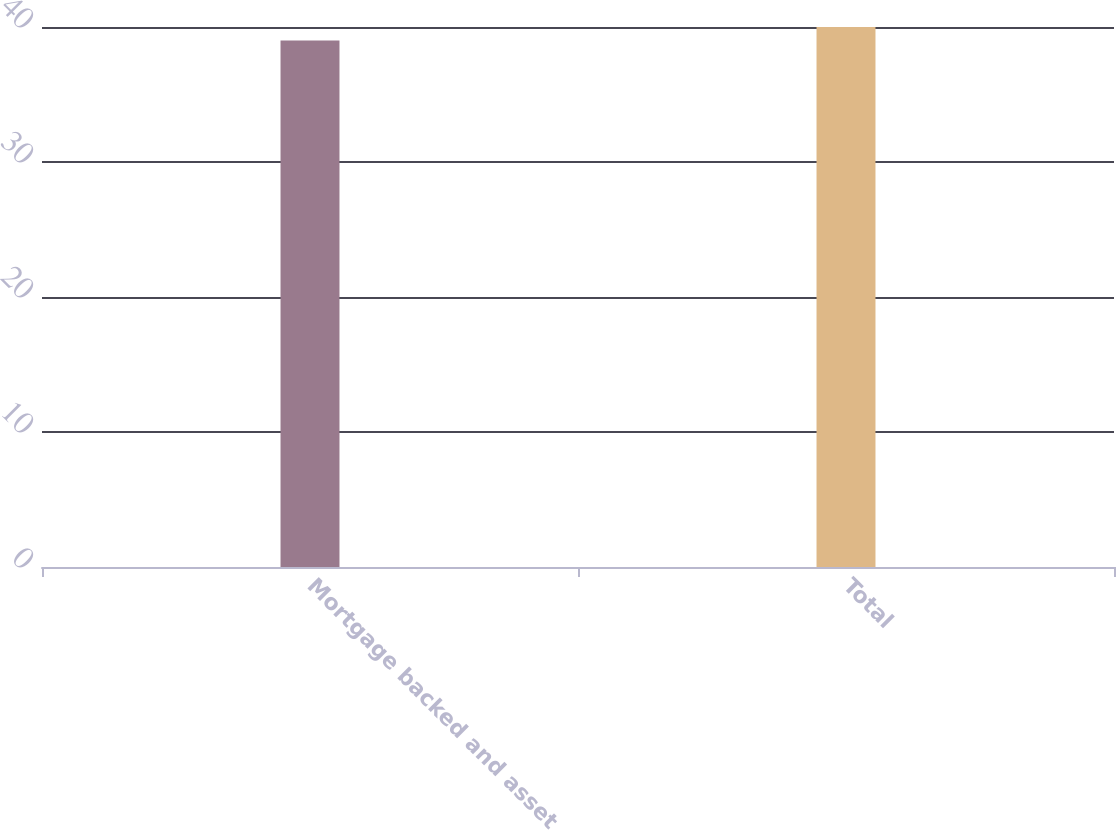Convert chart. <chart><loc_0><loc_0><loc_500><loc_500><bar_chart><fcel>Mortgage backed and asset<fcel>Total<nl><fcel>39<fcel>40<nl></chart> 